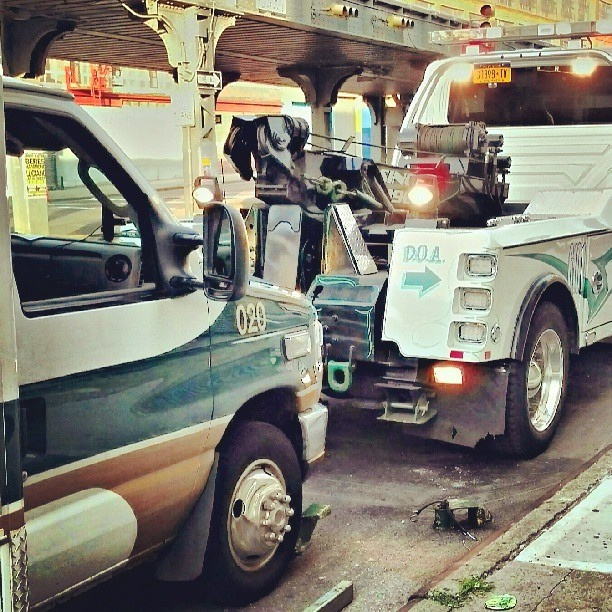Describe the objects in this image and their specific colors. I can see truck in black, beige, darkgray, and gray tones, truck in black, darkgray, gray, and beige tones, traffic light in black, khaki, tan, and beige tones, traffic light in black, tan, and khaki tones, and traffic light in black, brown, khaki, and maroon tones in this image. 